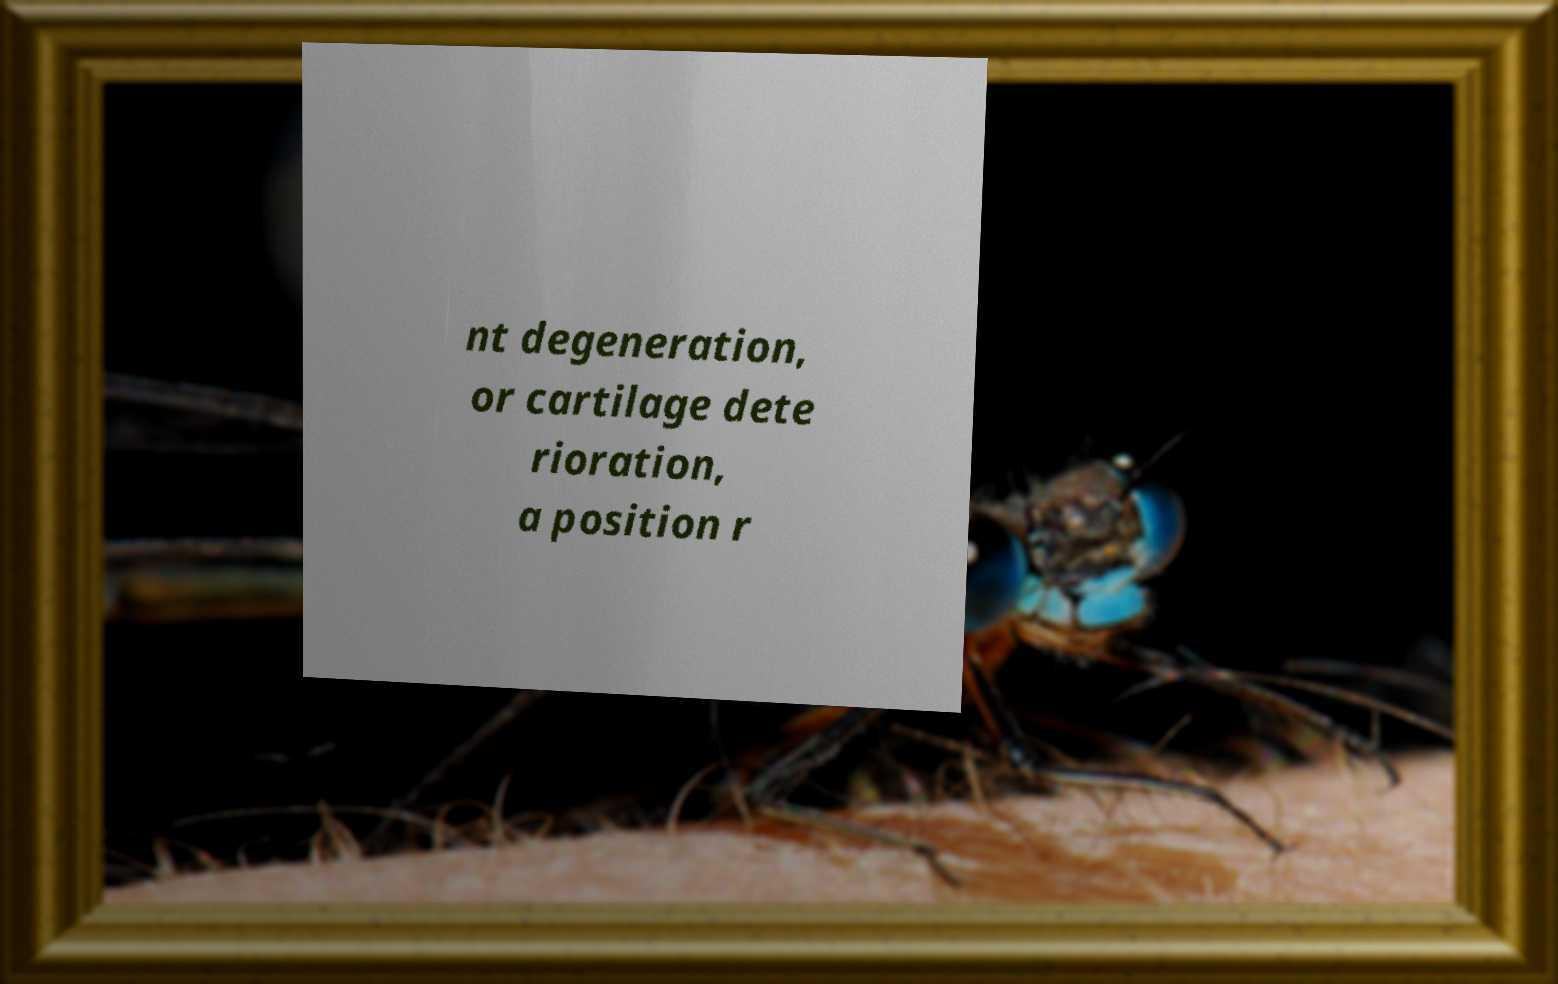Can you accurately transcribe the text from the provided image for me? nt degeneration, or cartilage dete rioration, a position r 